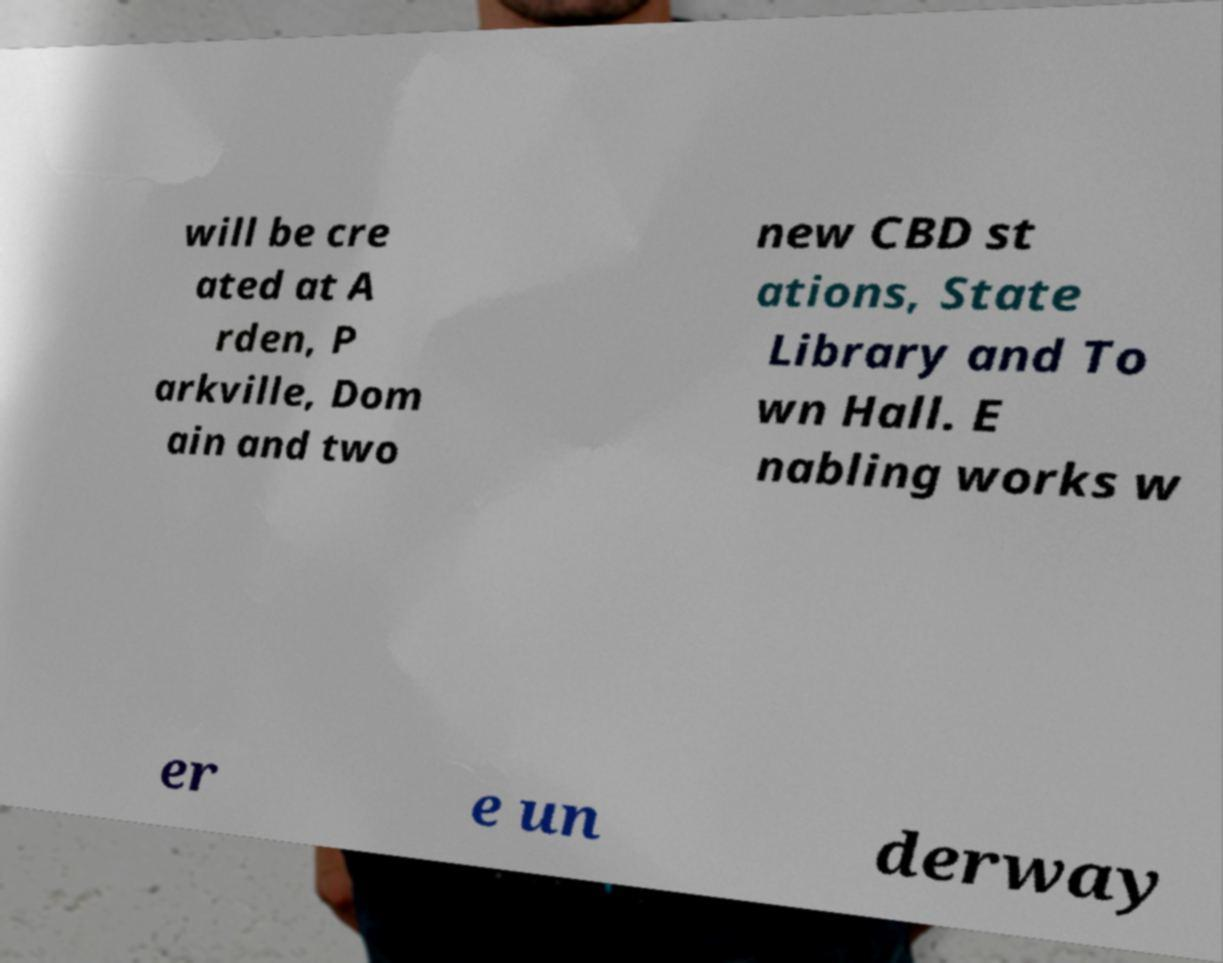Can you accurately transcribe the text from the provided image for me? will be cre ated at A rden, P arkville, Dom ain and two new CBD st ations, State Library and To wn Hall. E nabling works w er e un derway 